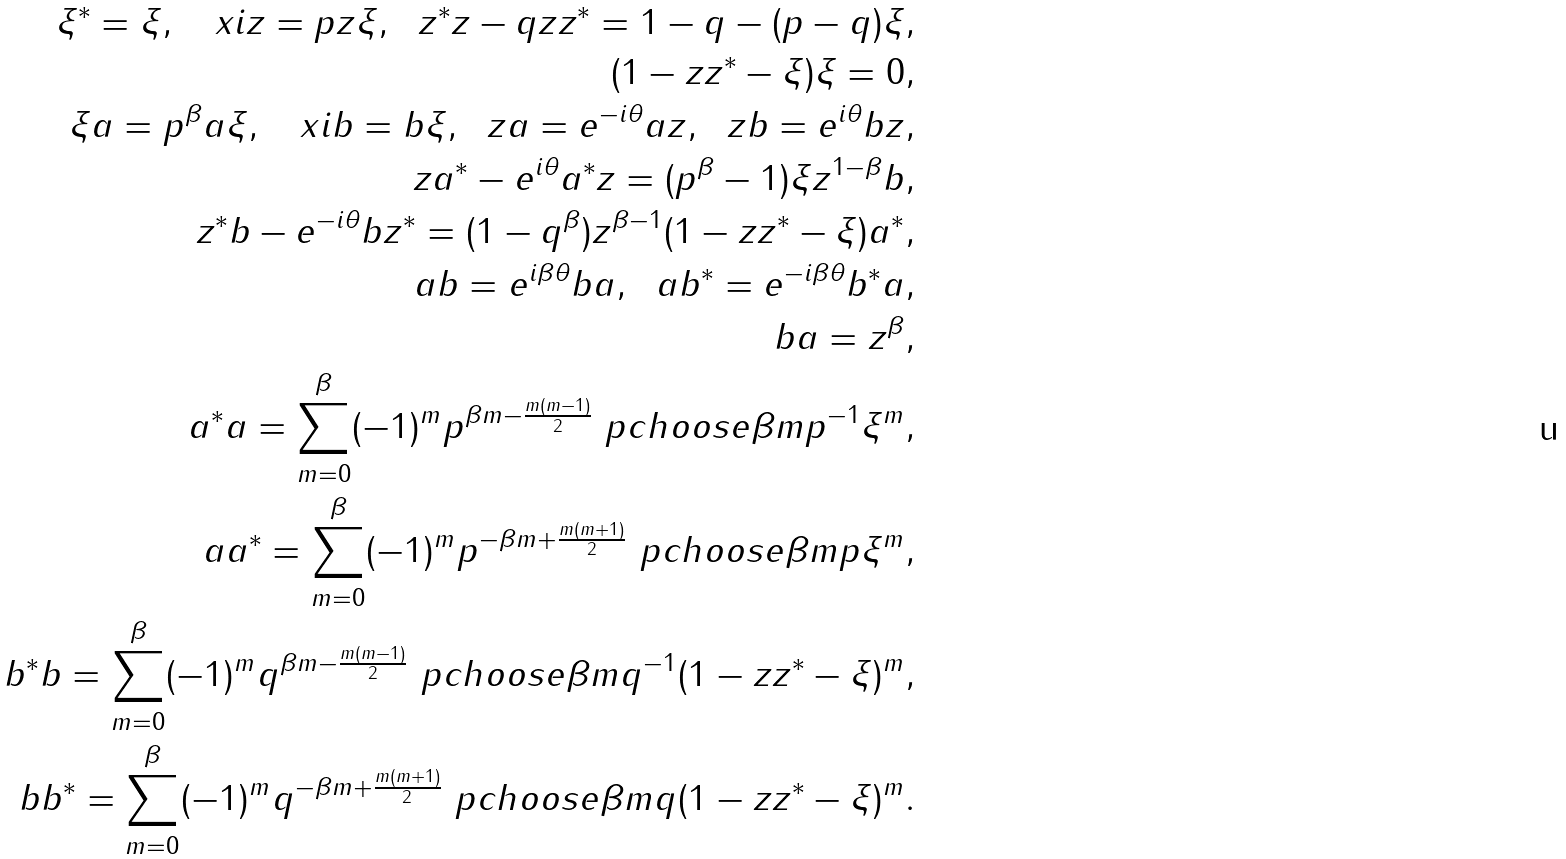Convert formula to latex. <formula><loc_0><loc_0><loc_500><loc_500>\xi ^ { \ast } = \xi , \quad x i z = p z \xi , \ \ z ^ { \ast } z - q z z ^ { \ast } = 1 - q - ( p - q ) \xi , \\ ( 1 - z z ^ { \ast } - \xi ) \xi = 0 , \\ \xi a = p ^ { \beta } a \xi , \quad x i b = b \xi , \ \ z a = e ^ { - i \theta } a z , \ \ z b = e ^ { i \theta } b z , \\ z a ^ { \ast } - e ^ { i \theta } a ^ { \ast } z = ( p ^ { \beta } - 1 ) \xi z ^ { 1 - \beta } b , \\ z ^ { \ast } b - e ^ { - i \theta } b z ^ { \ast } = ( 1 - q ^ { \beta } ) z ^ { \beta - 1 } ( 1 - z z ^ { \ast } - \xi ) a ^ { \ast } , \\ a b = e ^ { i \beta \theta } b a , \ \ a b ^ { \ast } = e ^ { - i \beta \theta } b ^ { \ast } a , \\ b a = z ^ { \beta } , \\ a ^ { \ast } a = \sum _ { m = 0 } ^ { \beta } ( - 1 ) ^ { m } p ^ { \beta m - \frac { m ( m - 1 ) } { 2 } } \ p c h o o s e { \beta } { m } { p ^ { - 1 } } \xi ^ { m } , \\ a a ^ { \ast } = \sum _ { m = 0 } ^ { \beta } ( - 1 ) ^ { m } p ^ { - \beta m + \frac { m ( m + 1 ) } { 2 } } \ p c h o o s e { \beta } { m } { p } \xi ^ { m } , \\ b ^ { \ast } b = \sum _ { m = 0 } ^ { \beta } ( - 1 ) ^ { m } q ^ { \beta m - \frac { m ( m - 1 ) } { 2 } } \ p c h o o s e { \beta } { m } { q ^ { - 1 } } ( 1 - z z ^ { \ast } - \xi ) ^ { m } , \\ b b ^ { \ast } = \sum _ { m = 0 } ^ { \beta } ( - 1 ) ^ { m } q ^ { - \beta m + \frac { m ( m + 1 ) } { 2 } } \ p c h o o s e { \beta } { m } { q } ( 1 - z z ^ { \ast } - \xi ) ^ { m } .</formula> 